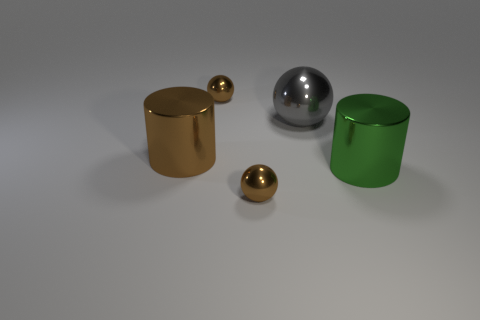Subtract all brown balls. How many balls are left? 1 Subtract all gray balls. How many balls are left? 2 Add 4 gray metal balls. How many objects exist? 9 Subtract all spheres. How many objects are left? 2 Subtract all red cylinders. Subtract all purple cubes. How many cylinders are left? 2 Subtract all green blocks. How many gray spheres are left? 1 Subtract all metal things. Subtract all red blocks. How many objects are left? 0 Add 2 balls. How many balls are left? 5 Add 4 green cylinders. How many green cylinders exist? 5 Subtract 0 green cubes. How many objects are left? 5 